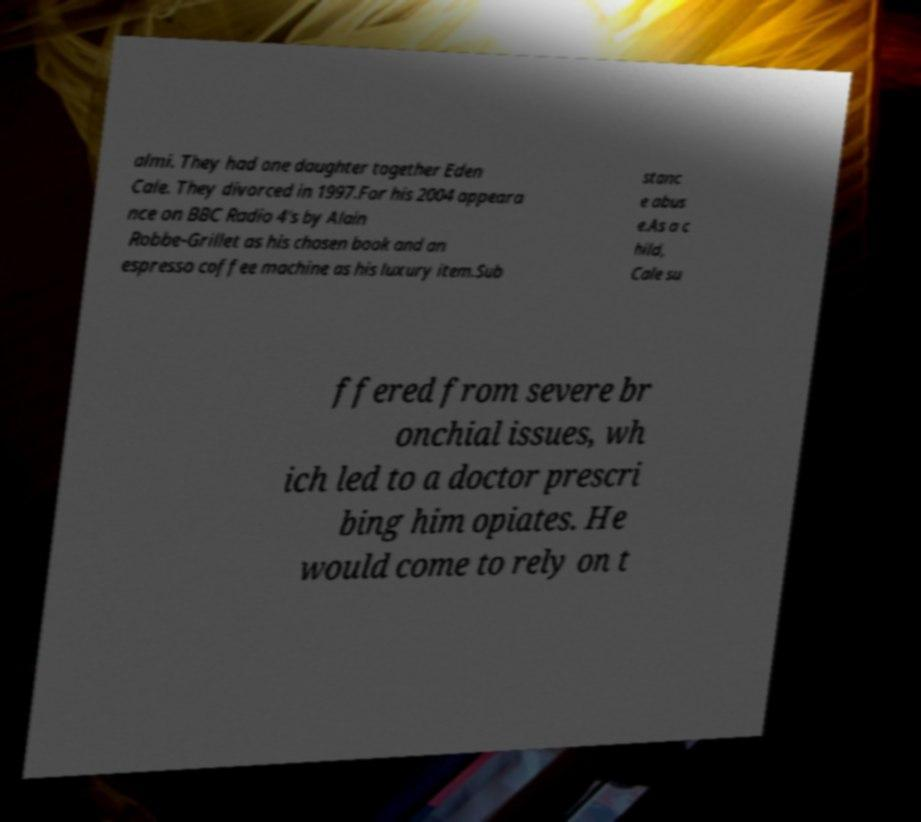Could you assist in decoding the text presented in this image and type it out clearly? almi. They had one daughter together Eden Cale. They divorced in 1997.For his 2004 appeara nce on BBC Radio 4's by Alain Robbe-Grillet as his chosen book and an espresso coffee machine as his luxury item.Sub stanc e abus e.As a c hild, Cale su ffered from severe br onchial issues, wh ich led to a doctor prescri bing him opiates. He would come to rely on t 